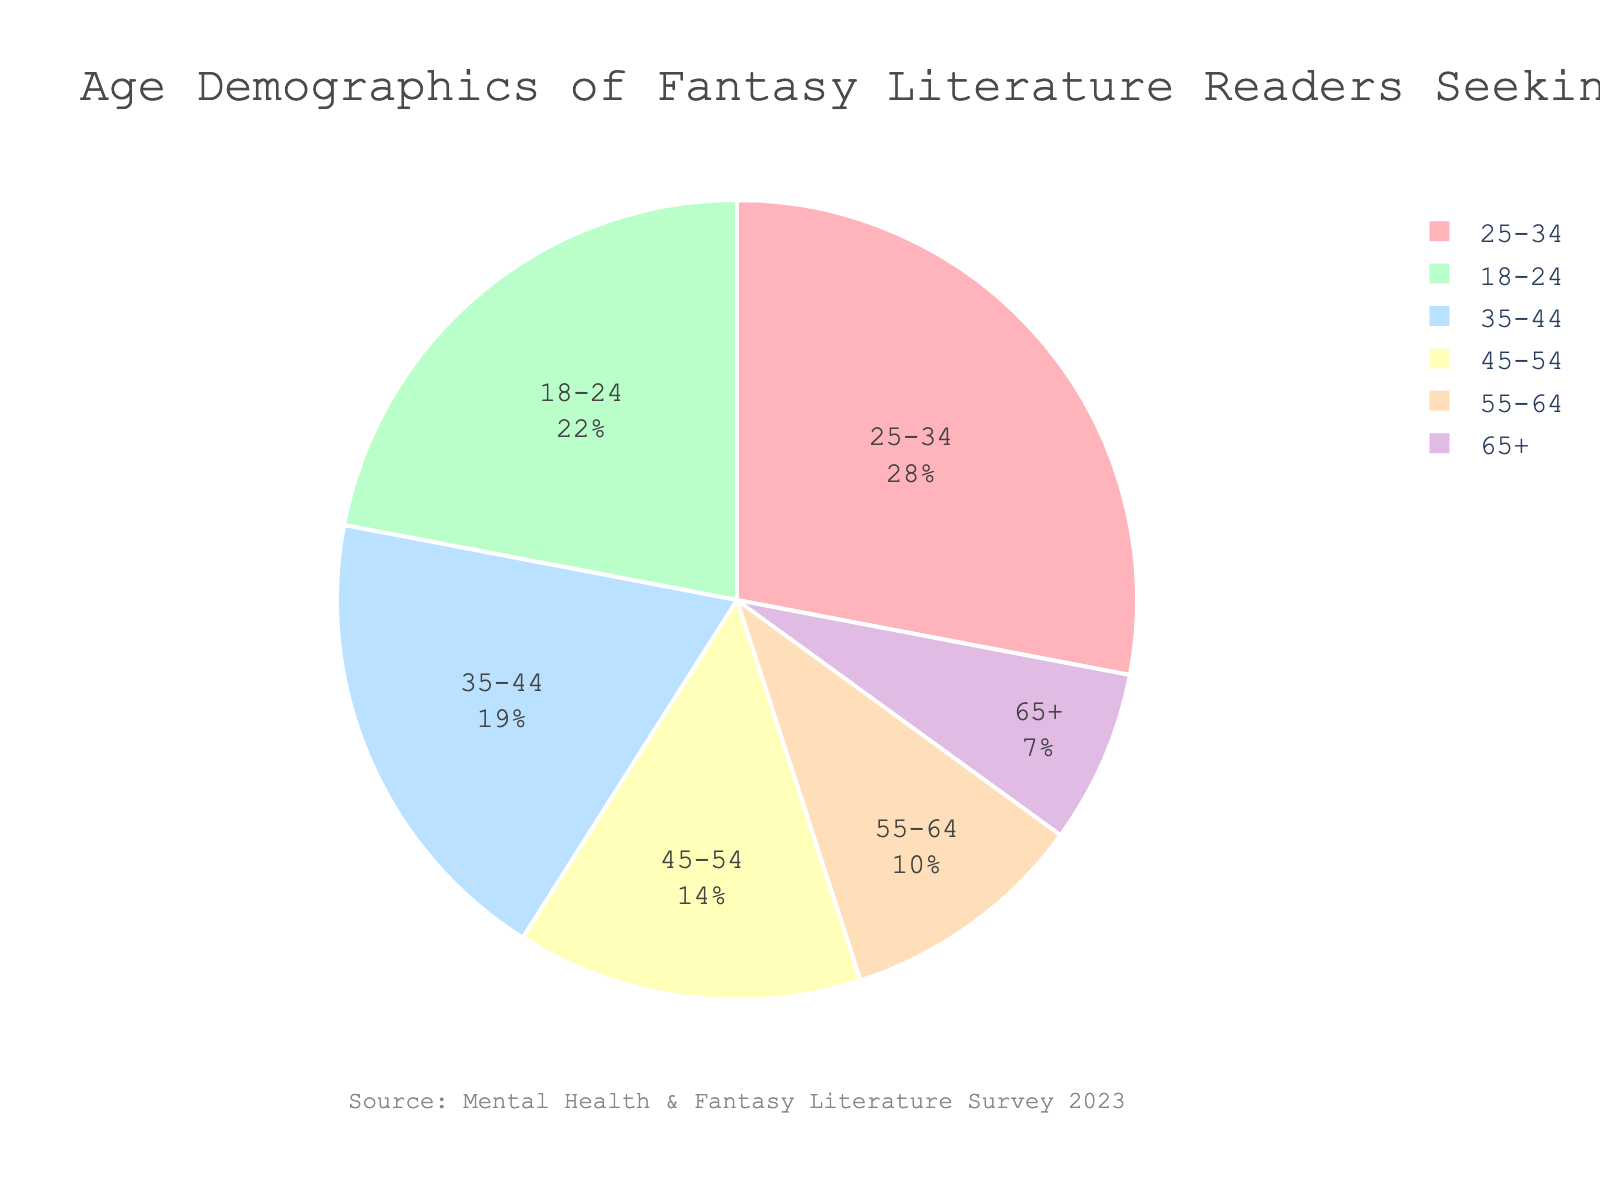Which age group has the highest percentage of fantasy literature readers seeking mental health support? To determine the highest percentage, look for the largest segment in the pie chart. The '25-34' age group has the largest segment.
Answer: 25-34 What is the sum of percentages for the age groups '18-24' and '35-44'? Add the percentages of the '18-24' age group (22) and the '35-44' age group (19). 22 + 19 = 41
Answer: 41 How does the percentage of the '25-34' age group compare to the '65+' age group? To compare the percentages, note that the '25-34' age group has 28%, and the '65+' age group has 7%. 28% is greater than 7%.
Answer: 25-34 is greater than 65+ Which age group has approximately twice the percentage of the '55-64' age group? The '55-64' age group has 10%. An age group with approximately twice this percentage would be around 20%. The '35-44' age group has 19%, which is closest to double 10%.
Answer: 35-44 What is the difference in percentage points between the '18-24' and '45-54' age groups? Subtract the percentage of the '45-54' age group (14) from the '18-24' age group (22). 22 - 14 = 8
Answer: 8 How do the combined percentages of the '45-54' and '55-64' age groups compare to the '25-34' age group? Add the percentages of the '45-54' (14) and '55-64' (10) age groups. 14 + 10 = 24. Compare this to '25-34' (28). 24 is less than 28.
Answer: Combined is less than 25-34 Which color represents the '65+' age group in the pie chart? Identify the segment representing the '65+' age group and note its color in the chart. The '65+' age group is in purple.
Answer: Purple Is the percentage of the '35-44' age group greater than the total percentage of '55-64' and '65+' age groups combined? Add the percentages of the '55-64' (10) and '65+' (7) age groups. 10 + 7 = 17. Compare this to the '35-44' age group (19). 19 is greater than 17.
Answer: Yes What is the difference in percentage between the two smallest age groups? Identify the two smallest age groups, which are '65+' (7) and '55-64' (10). Subtract the smaller percentage from the larger one. 10 - 7 = 3
Answer: 3 